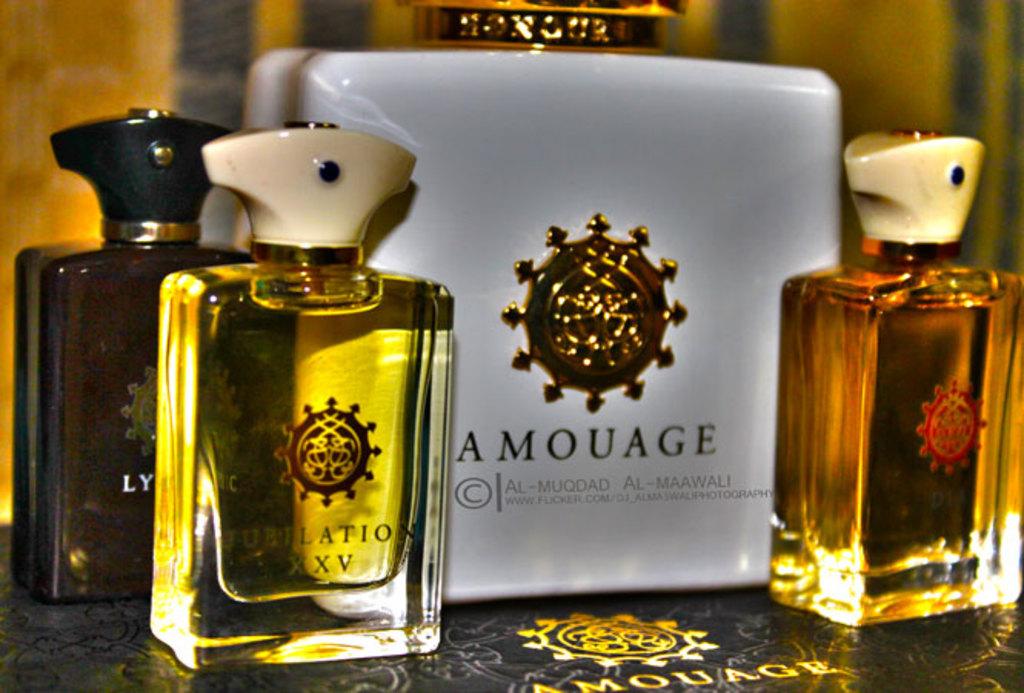What is the name of the bottle in the middle?
Keep it short and to the point. Amouage. 